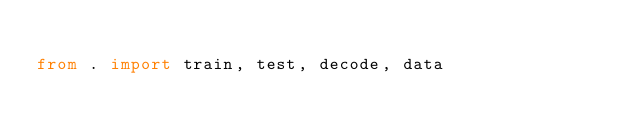Convert code to text. <code><loc_0><loc_0><loc_500><loc_500><_Python_>
from . import train, test, decode, data
</code> 